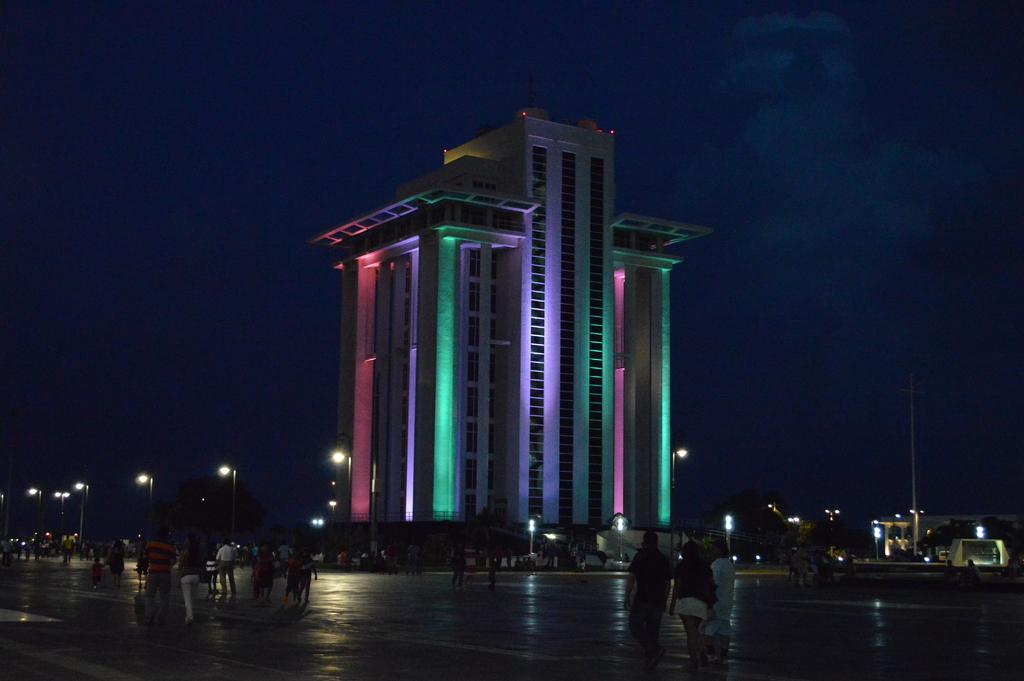Who or what can be seen in the image? There are people in the image. What structures are visible in the image? There are buildings in the image. What other objects can be seen in the image? There are light poles in the image. What part of the natural environment is visible in the image? The sky is visible in the image. What type of nerve can be seen in the image? There is no nerve present in the image. What kind of badge is being worn by the people in the image? There is no badge visible in the image. 